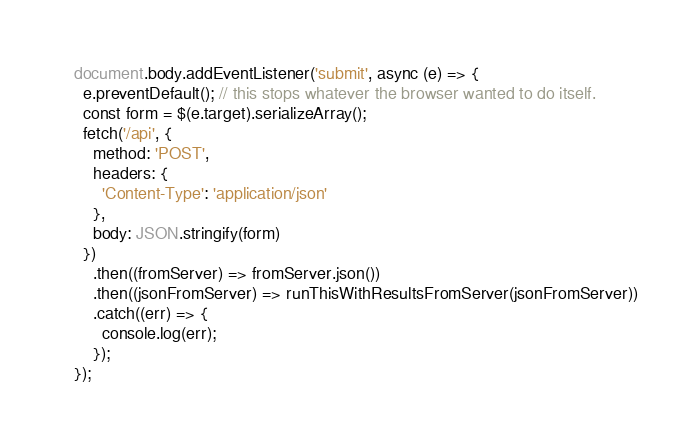<code> <loc_0><loc_0><loc_500><loc_500><_JavaScript_>document.body.addEventListener('submit', async (e) => {
  e.preventDefault(); // this stops whatever the browser wanted to do itself.
  const form = $(e.target).serializeArray();
  fetch('/api', {
    method: 'POST',
    headers: {
      'Content-Type': 'application/json'
    },
    body: JSON.stringify(form)
  })
    .then((fromServer) => fromServer.json())
    .then((jsonFromServer) => runThisWithResultsFromServer(jsonFromServer))
    .catch((err) => {
      console.log(err);
    });
});</code> 